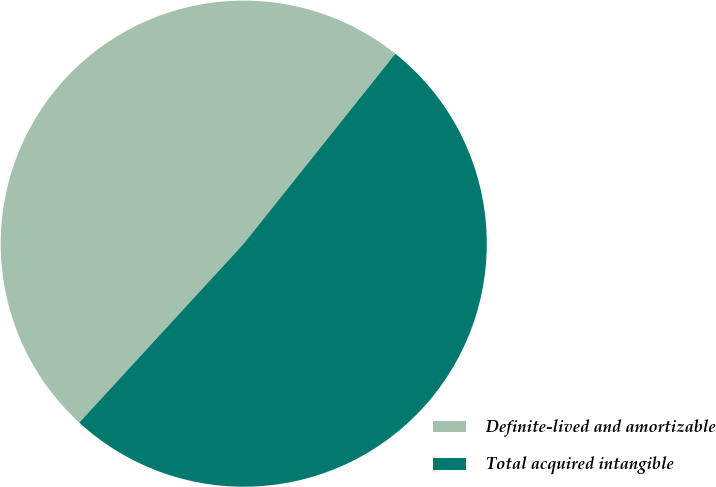<chart> <loc_0><loc_0><loc_500><loc_500><pie_chart><fcel>Definite-lived and amortizable<fcel>Total acquired intangible<nl><fcel>48.89%<fcel>51.11%<nl></chart> 